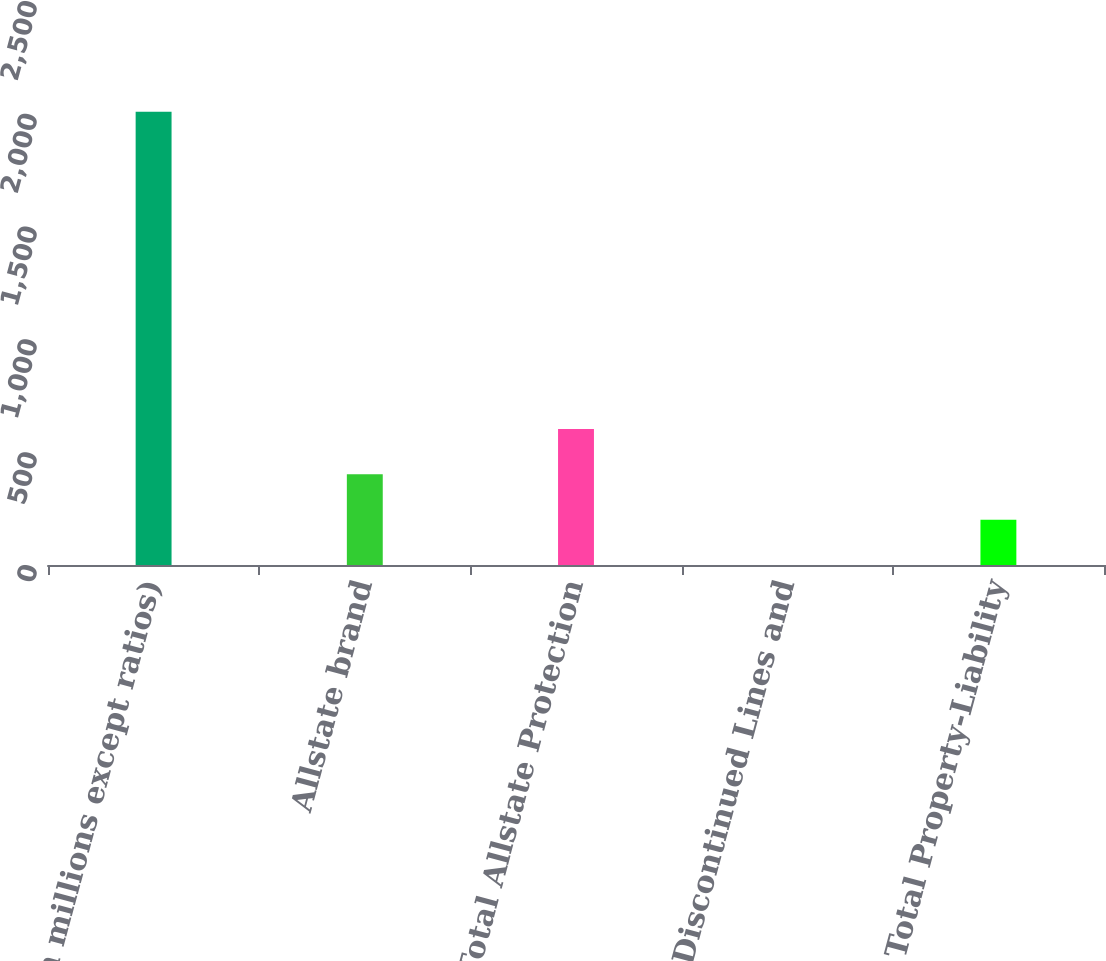Convert chart. <chart><loc_0><loc_0><loc_500><loc_500><bar_chart><fcel>( in millions except ratios)<fcel>Allstate brand<fcel>Total Allstate Protection<fcel>Discontinued Lines and<fcel>Total Property-Liability<nl><fcel>2009<fcel>401.88<fcel>602.77<fcel>0.1<fcel>200.99<nl></chart> 